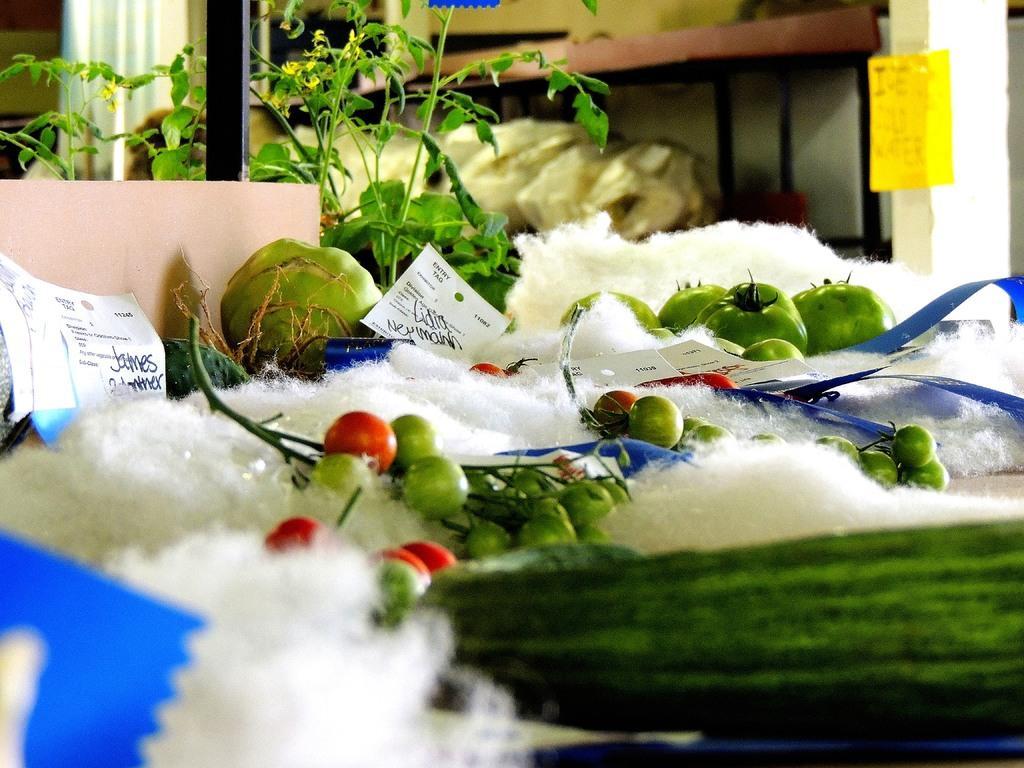Please provide a concise description of this image. In this image we can see some objects and we can see some vegetables like tomatoes and at the background we can see some objects on the rack. left side we can see some plants. 